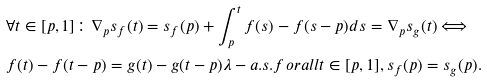Convert formula to latex. <formula><loc_0><loc_0><loc_500><loc_500>& \forall t \in [ p , 1 ] \colon \nabla _ { p } s _ { f } ( t ) = s _ { f } ( p ) + \int _ { p } ^ { t } f ( s ) - f ( s - p ) d s = \nabla _ { p } s _ { g } ( t ) \Longleftrightarrow \\ & f ( t ) - f ( t - p ) = g ( t ) - g ( t - p ) \lambda - a . s . f o r a l l t \in [ p , 1 ] , s _ { f } ( p ) = s _ { g } ( p ) .</formula> 